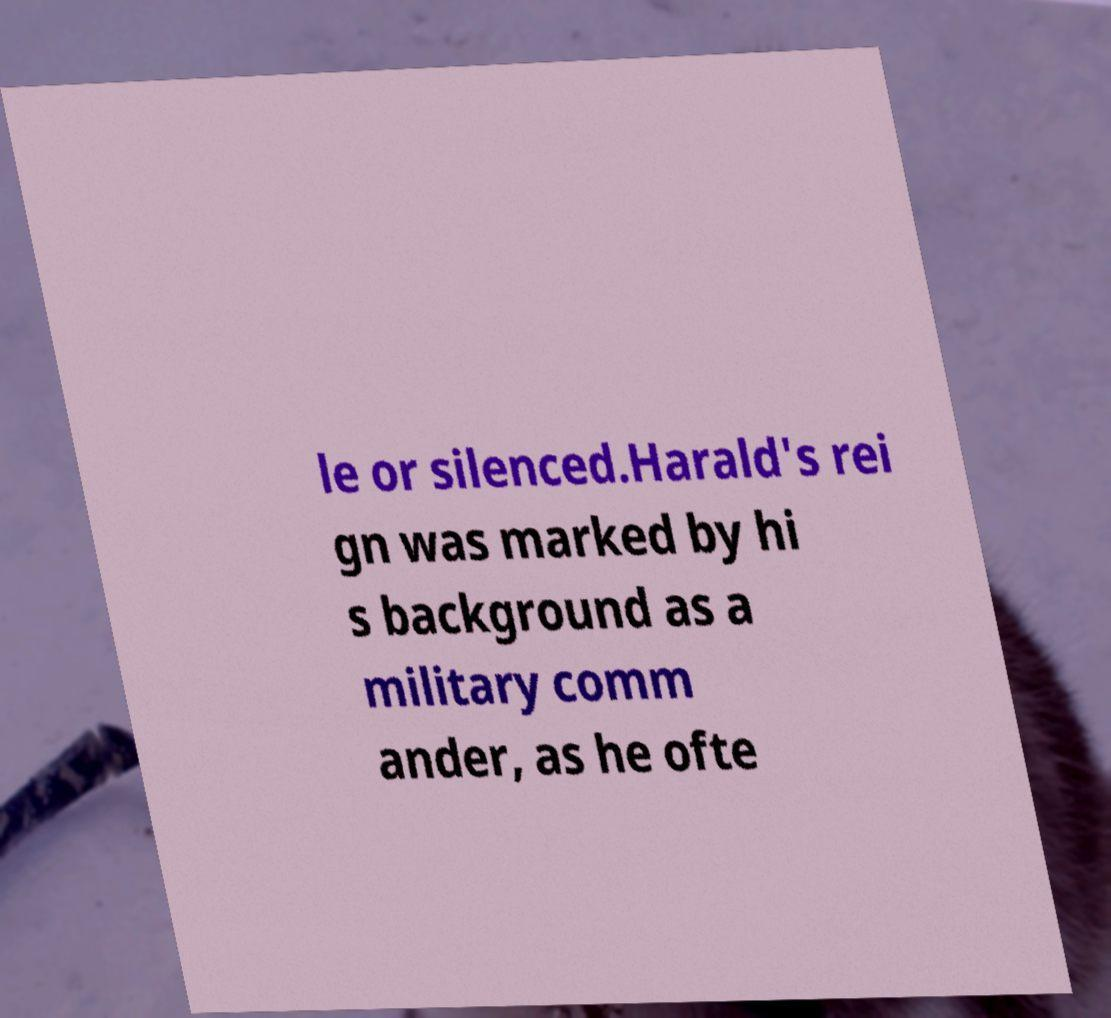There's text embedded in this image that I need extracted. Can you transcribe it verbatim? le or silenced.Harald's rei gn was marked by hi s background as a military comm ander, as he ofte 